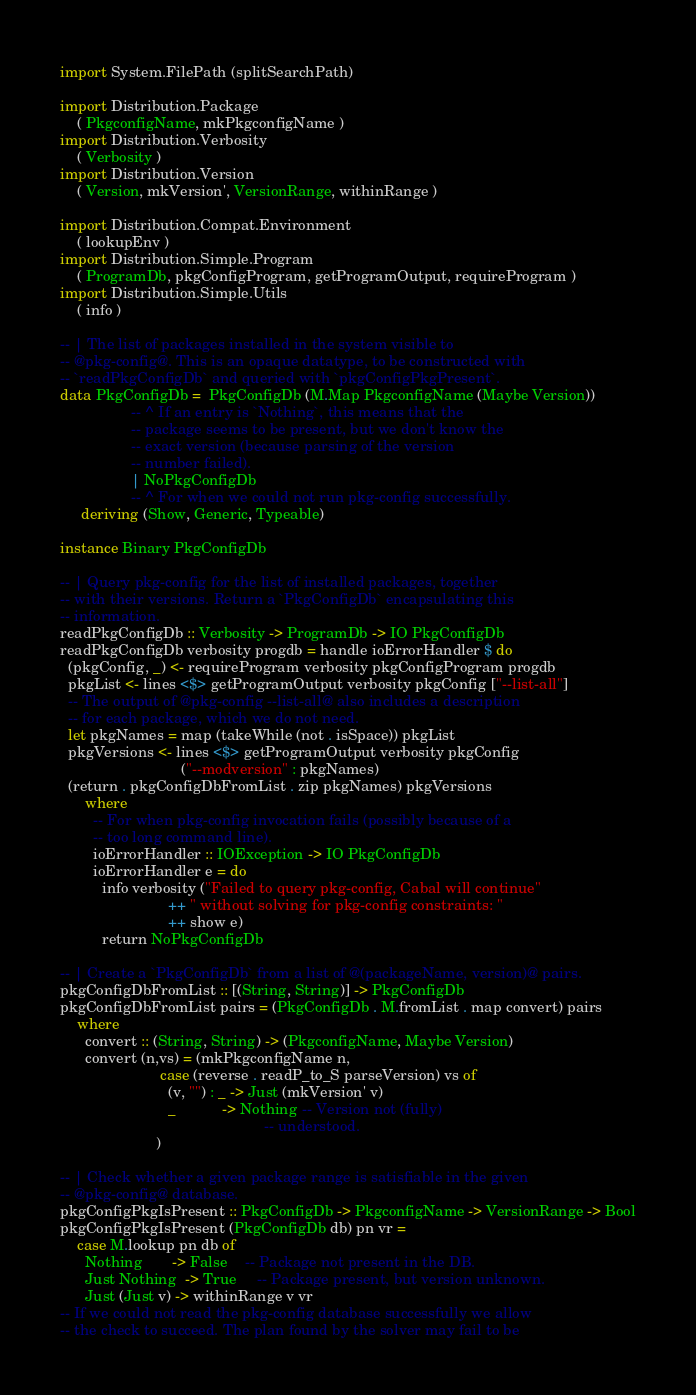Convert code to text. <code><loc_0><loc_0><loc_500><loc_500><_Haskell_>import System.FilePath (splitSearchPath)

import Distribution.Package
    ( PkgconfigName, mkPkgconfigName )
import Distribution.Verbosity
    ( Verbosity )
import Distribution.Version
    ( Version, mkVersion', VersionRange, withinRange )

import Distribution.Compat.Environment
    ( lookupEnv )
import Distribution.Simple.Program
    ( ProgramDb, pkgConfigProgram, getProgramOutput, requireProgram )
import Distribution.Simple.Utils
    ( info )

-- | The list of packages installed in the system visible to
-- @pkg-config@. This is an opaque datatype, to be constructed with
-- `readPkgConfigDb` and queried with `pkgConfigPkgPresent`.
data PkgConfigDb =  PkgConfigDb (M.Map PkgconfigName (Maybe Version))
                 -- ^ If an entry is `Nothing`, this means that the
                 -- package seems to be present, but we don't know the
                 -- exact version (because parsing of the version
                 -- number failed).
                 | NoPkgConfigDb
                 -- ^ For when we could not run pkg-config successfully.
     deriving (Show, Generic, Typeable)

instance Binary PkgConfigDb

-- | Query pkg-config for the list of installed packages, together
-- with their versions. Return a `PkgConfigDb` encapsulating this
-- information.
readPkgConfigDb :: Verbosity -> ProgramDb -> IO PkgConfigDb
readPkgConfigDb verbosity progdb = handle ioErrorHandler $ do
  (pkgConfig, _) <- requireProgram verbosity pkgConfigProgram progdb
  pkgList <- lines <$> getProgramOutput verbosity pkgConfig ["--list-all"]
  -- The output of @pkg-config --list-all@ also includes a description
  -- for each package, which we do not need.
  let pkgNames = map (takeWhile (not . isSpace)) pkgList
  pkgVersions <- lines <$> getProgramOutput verbosity pkgConfig
                             ("--modversion" : pkgNames)
  (return . pkgConfigDbFromList . zip pkgNames) pkgVersions
      where
        -- For when pkg-config invocation fails (possibly because of a
        -- too long command line).
        ioErrorHandler :: IOException -> IO PkgConfigDb
        ioErrorHandler e = do
          info verbosity ("Failed to query pkg-config, Cabal will continue"
                          ++ " without solving for pkg-config constraints: "
                          ++ show e)
          return NoPkgConfigDb

-- | Create a `PkgConfigDb` from a list of @(packageName, version)@ pairs.
pkgConfigDbFromList :: [(String, String)] -> PkgConfigDb
pkgConfigDbFromList pairs = (PkgConfigDb . M.fromList . map convert) pairs
    where
      convert :: (String, String) -> (PkgconfigName, Maybe Version)
      convert (n,vs) = (mkPkgconfigName n,
                        case (reverse . readP_to_S parseVersion) vs of
                          (v, "") : _ -> Just (mkVersion' v)
                          _           -> Nothing -- Version not (fully)
                                                 -- understood.
                       )

-- | Check whether a given package range is satisfiable in the given
-- @pkg-config@ database.
pkgConfigPkgIsPresent :: PkgConfigDb -> PkgconfigName -> VersionRange -> Bool
pkgConfigPkgIsPresent (PkgConfigDb db) pn vr =
    case M.lookup pn db of
      Nothing       -> False    -- Package not present in the DB.
      Just Nothing  -> True     -- Package present, but version unknown.
      Just (Just v) -> withinRange v vr
-- If we could not read the pkg-config database successfully we allow
-- the check to succeed. The plan found by the solver may fail to be</code> 